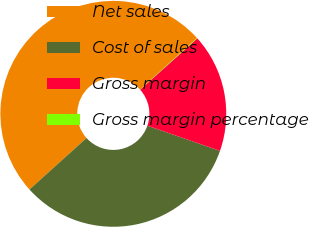Convert chart. <chart><loc_0><loc_0><loc_500><loc_500><pie_chart><fcel>Net sales<fcel>Cost of sales<fcel>Gross margin<fcel>Gross margin percentage<nl><fcel>49.96%<fcel>32.99%<fcel>16.97%<fcel>0.07%<nl></chart> 